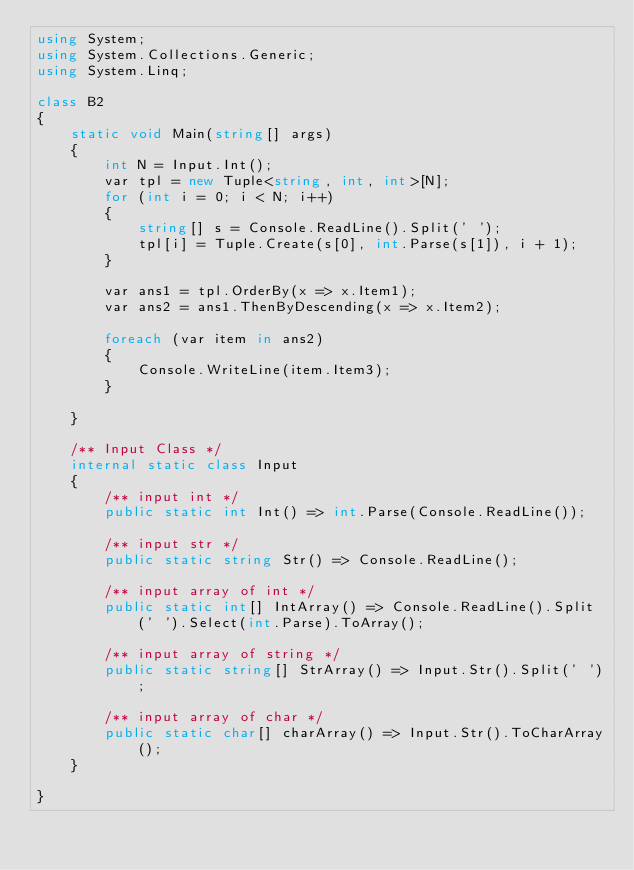Convert code to text. <code><loc_0><loc_0><loc_500><loc_500><_C#_>using System;
using System.Collections.Generic;
using System.Linq;

class B2
{
    static void Main(string[] args)
    {
        int N = Input.Int();
        var tpl = new Tuple<string, int, int>[N];
        for (int i = 0; i < N; i++)
        {
            string[] s = Console.ReadLine().Split(' ');
            tpl[i] = Tuple.Create(s[0], int.Parse(s[1]), i + 1);
        }

        var ans1 = tpl.OrderBy(x => x.Item1);
        var ans2 = ans1.ThenByDescending(x => x.Item2);

        foreach (var item in ans2)
        {
            Console.WriteLine(item.Item3);
        }

    }

    /** Input Class */
    internal static class Input
    {
        /** input int */
        public static int Int() => int.Parse(Console.ReadLine());

        /** input str */
        public static string Str() => Console.ReadLine();

        /** input array of int */
        public static int[] IntArray() => Console.ReadLine().Split(' ').Select(int.Parse).ToArray();

        /** input array of string */
        public static string[] StrArray() => Input.Str().Split(' ');

        /** input array of char */
        public static char[] charArray() => Input.Str().ToCharArray();
    }

}</code> 